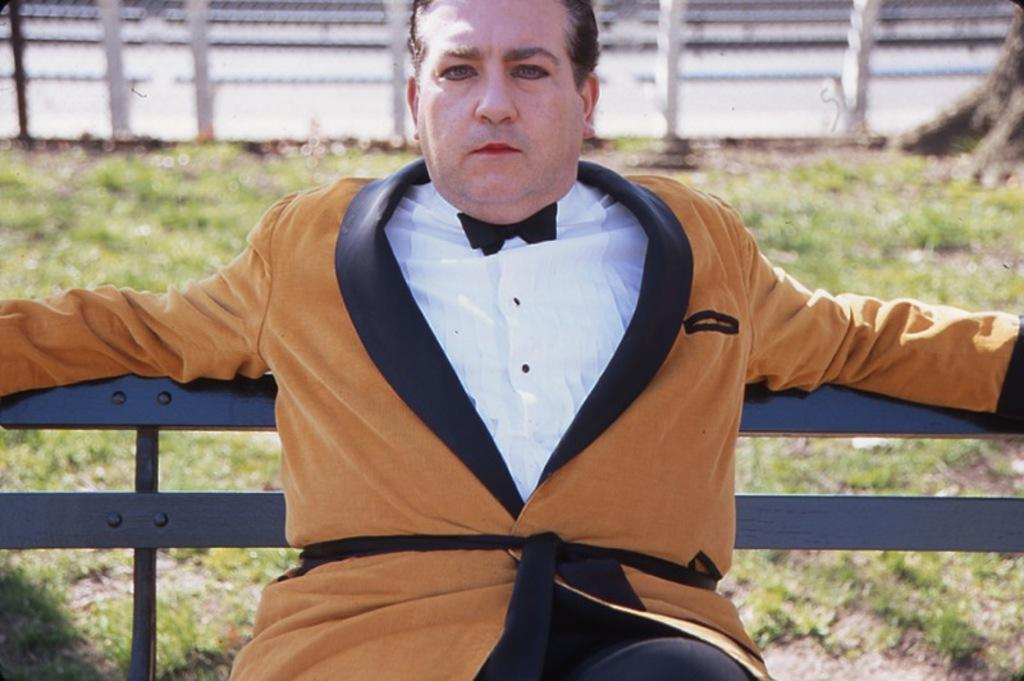What is the man in the image doing? The man is sitting on a bench in the image. What type of surface is visible beneath the man? There is grass visible in the image. What part of a tree can be seen in the image? The bark of a tree is present in the image. What type of barrier is visible in the image? There is a fence in the image. What type of nut is being cracked by the man in the image? There is no nut present in the image, nor is the man shown cracking one. 